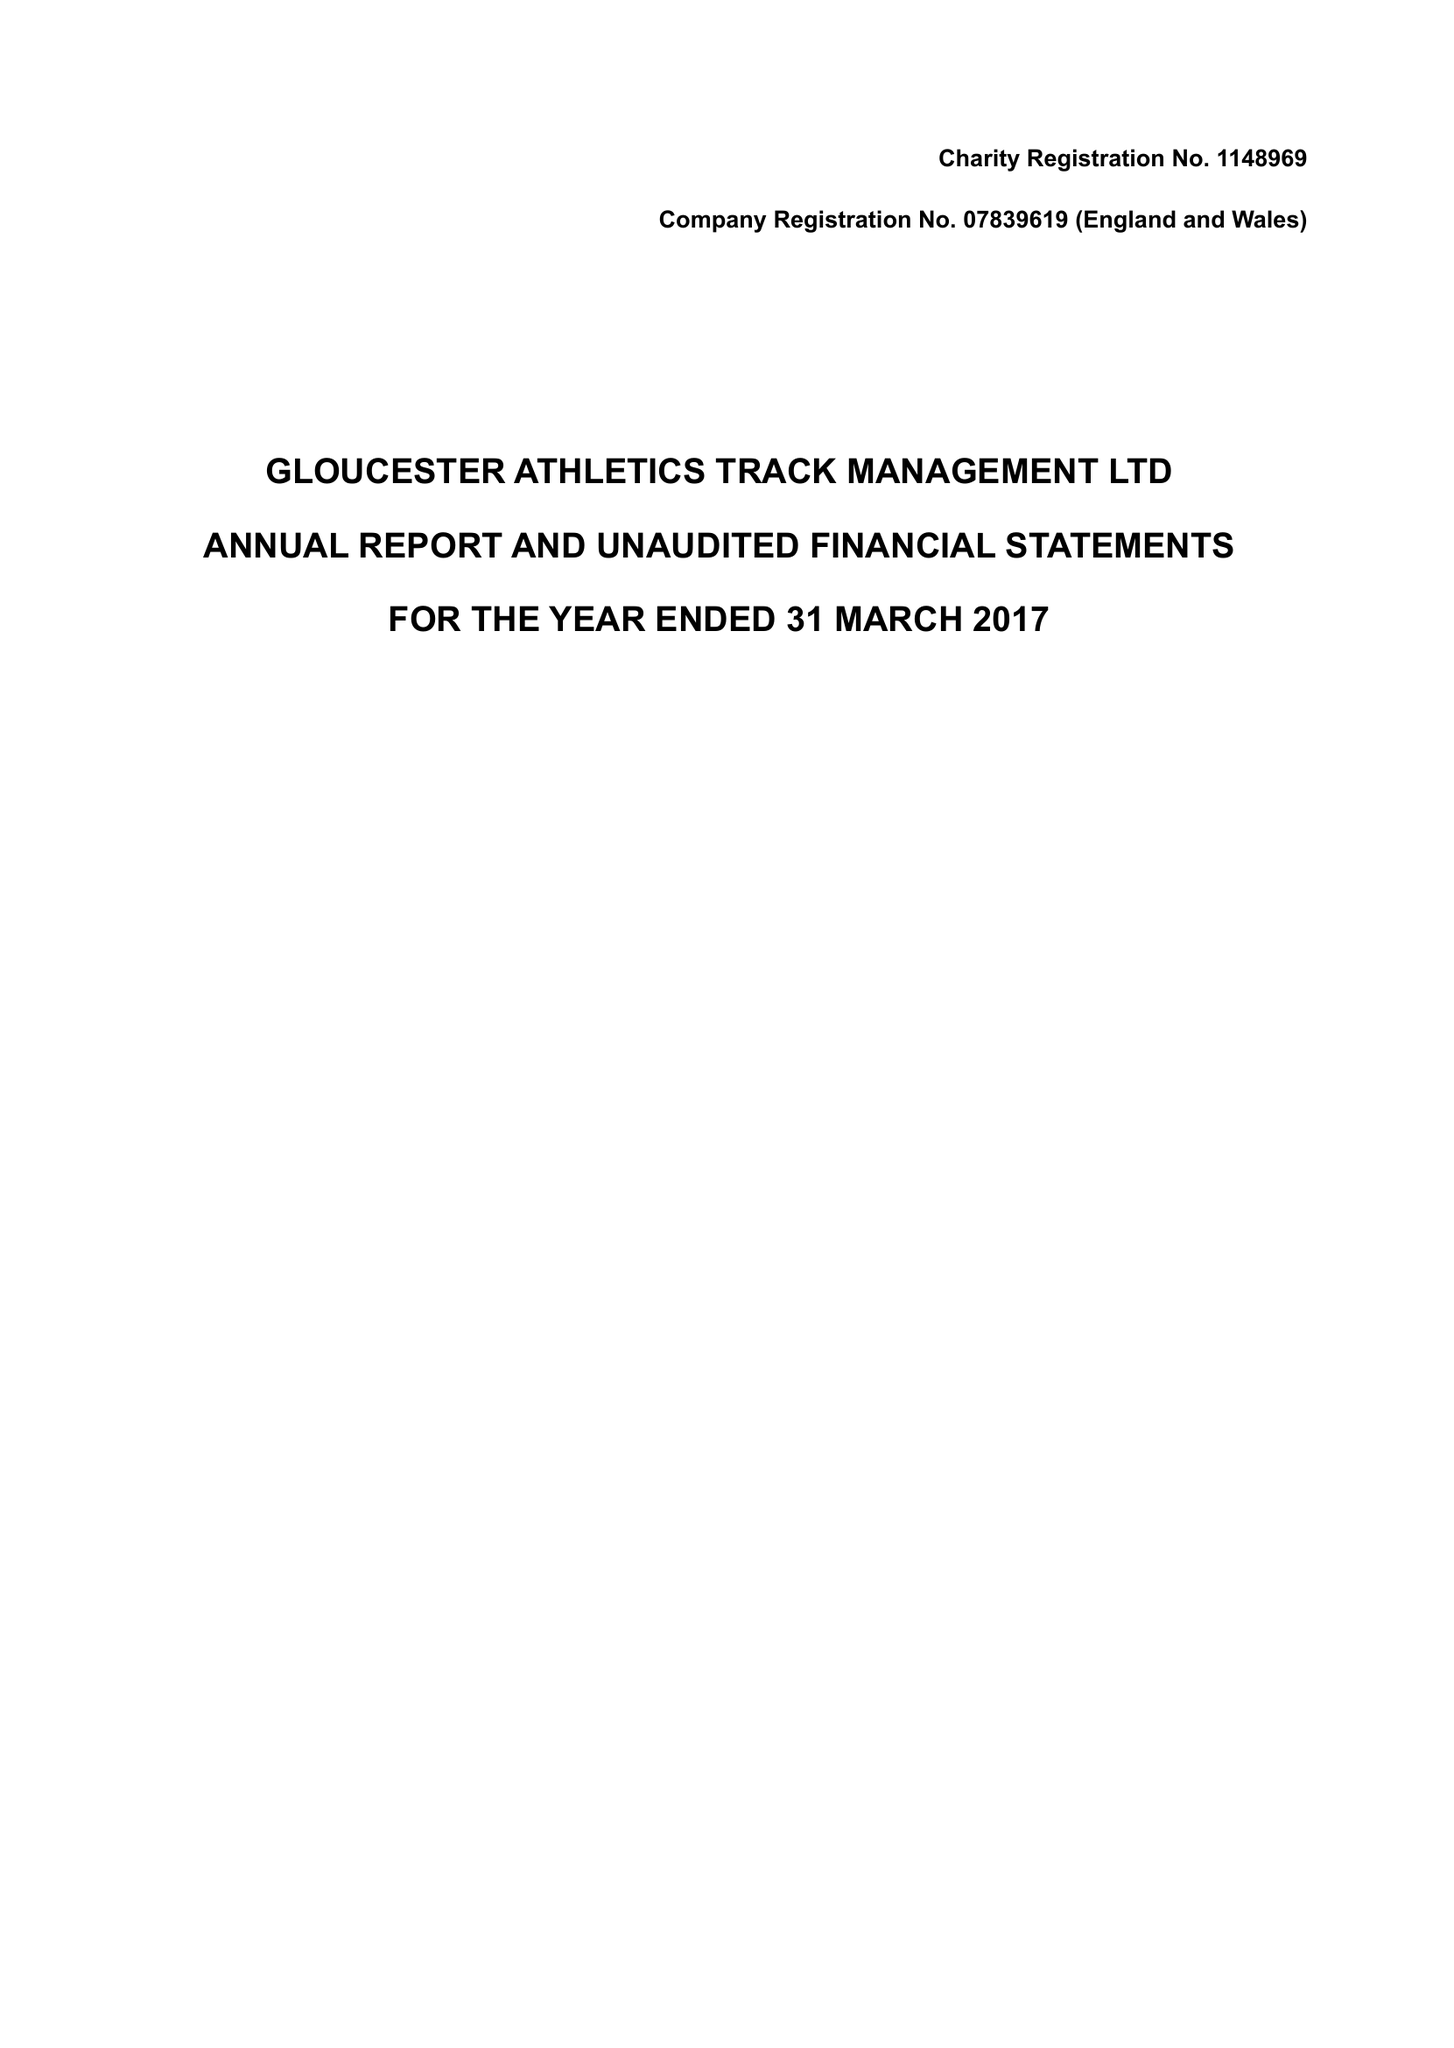What is the value for the income_annually_in_british_pounds?
Answer the question using a single word or phrase. 28160.00 